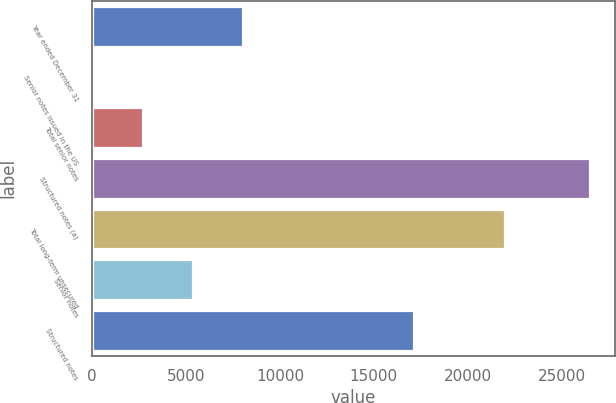Convert chart to OTSL. <chart><loc_0><loc_0><loc_500><loc_500><bar_chart><fcel>Year ended December 31<fcel>Senior notes issued in the US<fcel>Total senior notes<fcel>Structured notes (a)<fcel>Total long-term unsecured<fcel>Senior notes<fcel>Structured notes<nl><fcel>8019.2<fcel>62<fcel>2714.4<fcel>26524<fcel>22007<fcel>5366.8<fcel>17141<nl></chart> 